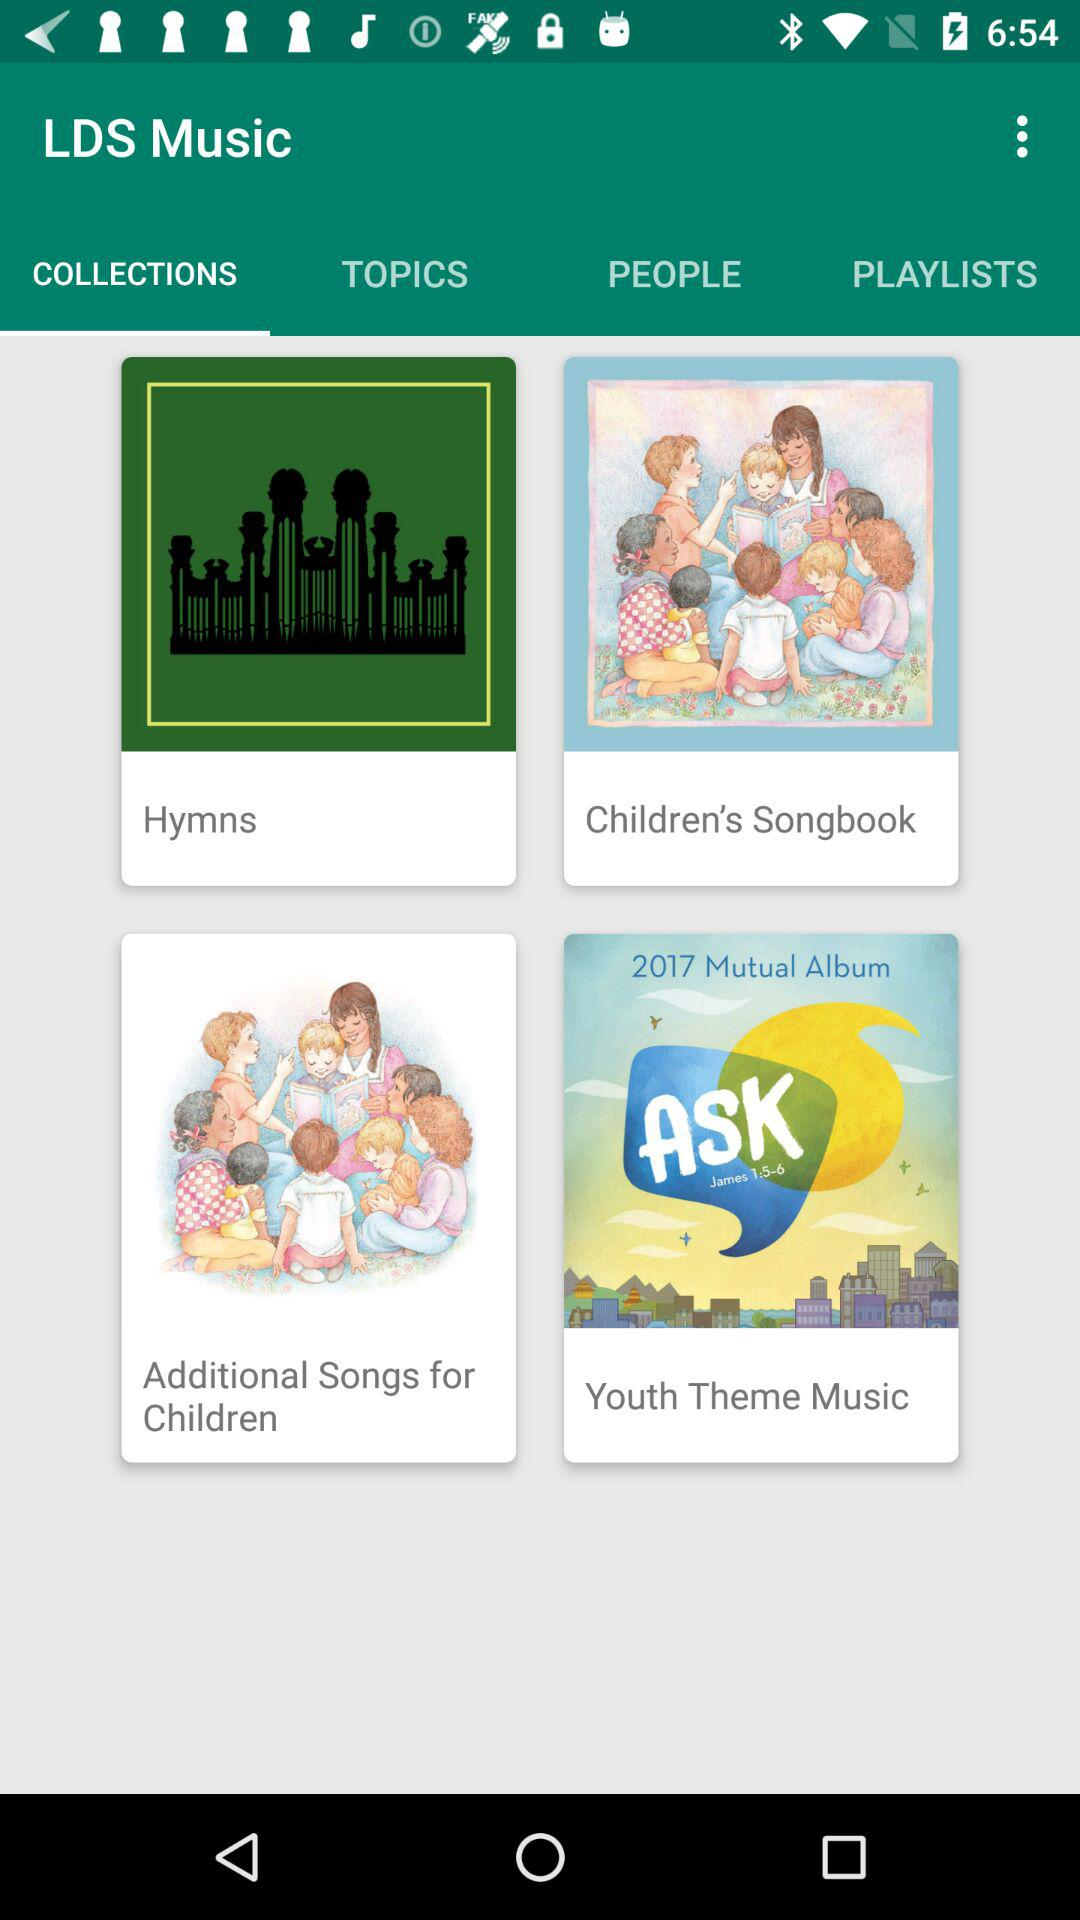What is the application name? The application name is "LDS Music". 